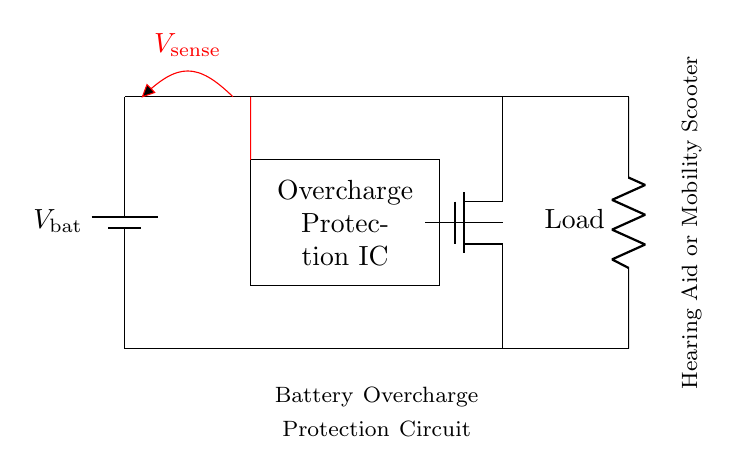What is the type of the battery shown? The circuit diagram shows a battery labeled as V_bat, which represents a typical battery used in electronic devices.
Answer: battery What component is responsible for overcharge protection? The component labeled "Overcharge Protection IC" in the circuit diagram is designated specifically for this function, preventing excessive charging.
Answer: Overcharge Protection IC What load is connected in this circuit? The circuit diagram connects a resistor labeled as 'Load', which represents the active component powered by the battery.
Answer: Load How many main components are there in the circuit? Counting the battery, Overcharge Protection IC, MOSFET, and Load gives a total of four main components in the circuit.
Answer: four What is the significance of V_sense in this circuit? The voltage labeled V_sense is utilized to monitor the battery voltage and ensure it remains within safe charging limits, as part of the protection mechanism.
Answer: monitoring voltage Which component controls the flow of current to the load? The MOSFET shown in the circuit diagram is responsible for controlling current flow from the battery to the load based on signals from the Overcharge Protection IC.
Answer: MOSFET What does the red line represent in the circuit? The red line marked with V_sense indicates the voltage sensing connection, which is crucial for detecting the battery’s charge level and initiating protection if overcharging occurs.
Answer: voltage sensing connection 